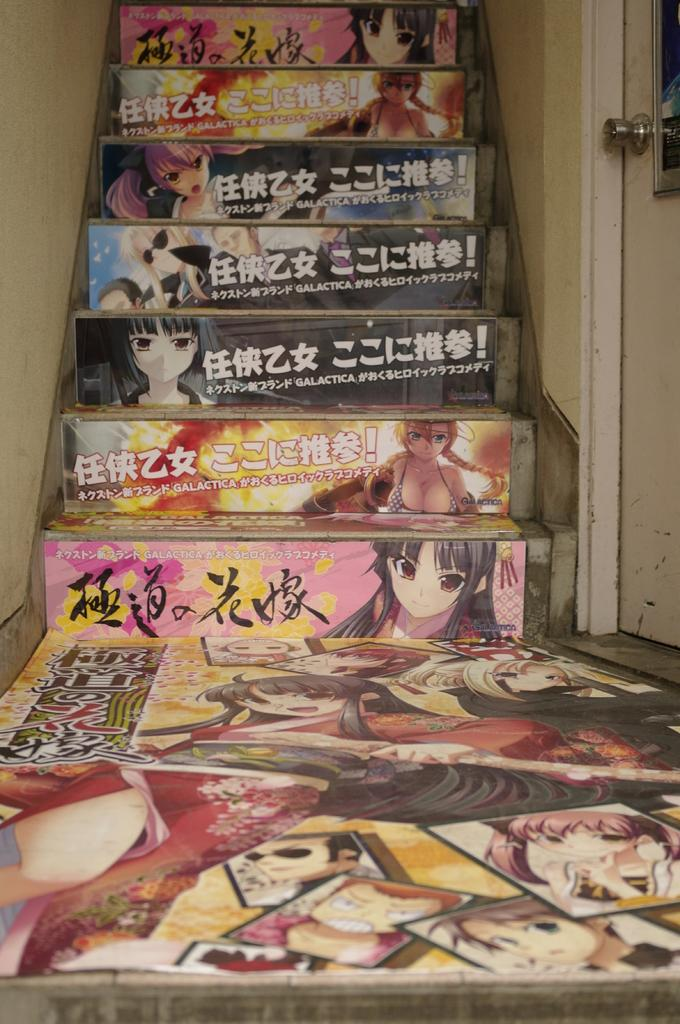What type of structure is present in the image? There is a staircase in the image. What can be seen on the staircase? There are posters on the staircase. What is located on the right side of the staircase? There is a wall on the right side of the staircase. Can you identify any other structures in the image? Yes, there is a door in the image. What is the tax rate for the sleet in the image? There is no mention of tax or sleet in the image, as it features a staircase with posters, a wall, and a door. 